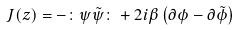Convert formula to latex. <formula><loc_0><loc_0><loc_500><loc_500>J ( z ) = - \colon \psi \tilde { \psi } \colon + 2 i \beta \left ( \partial \phi - \partial \tilde { \phi } \right )</formula> 